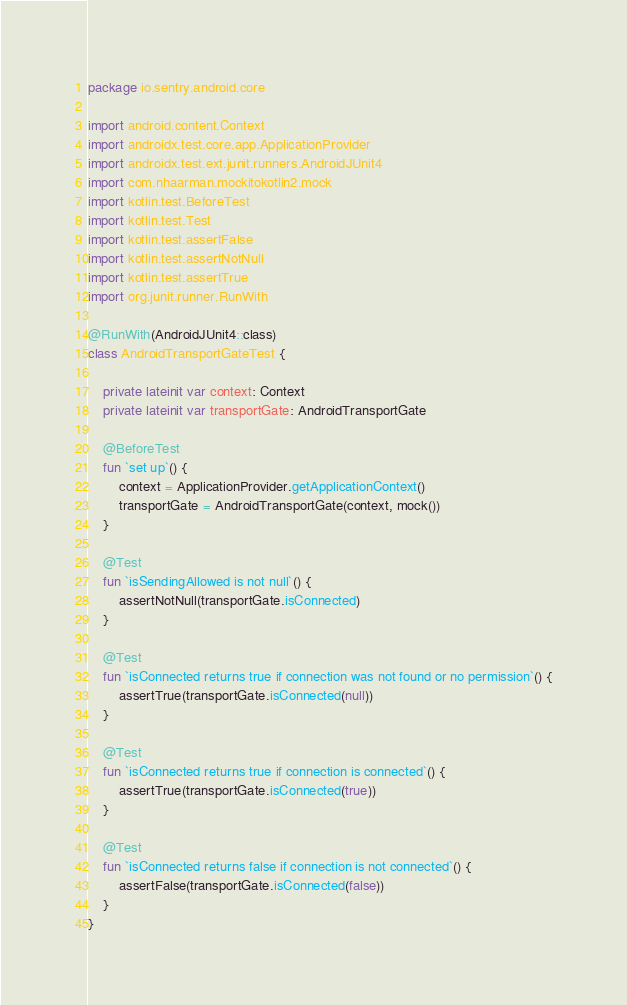<code> <loc_0><loc_0><loc_500><loc_500><_Kotlin_>package io.sentry.android.core

import android.content.Context
import androidx.test.core.app.ApplicationProvider
import androidx.test.ext.junit.runners.AndroidJUnit4
import com.nhaarman.mockitokotlin2.mock
import kotlin.test.BeforeTest
import kotlin.test.Test
import kotlin.test.assertFalse
import kotlin.test.assertNotNull
import kotlin.test.assertTrue
import org.junit.runner.RunWith

@RunWith(AndroidJUnit4::class)
class AndroidTransportGateTest {

    private lateinit var context: Context
    private lateinit var transportGate: AndroidTransportGate

    @BeforeTest
    fun `set up`() {
        context = ApplicationProvider.getApplicationContext()
        transportGate = AndroidTransportGate(context, mock())
    }

    @Test
    fun `isSendingAllowed is not null`() {
        assertNotNull(transportGate.isConnected)
    }

    @Test
    fun `isConnected returns true if connection was not found or no permission`() {
        assertTrue(transportGate.isConnected(null))
    }

    @Test
    fun `isConnected returns true if connection is connected`() {
        assertTrue(transportGate.isConnected(true))
    }

    @Test
    fun `isConnected returns false if connection is not connected`() {
        assertFalse(transportGate.isConnected(false))
    }
}
</code> 